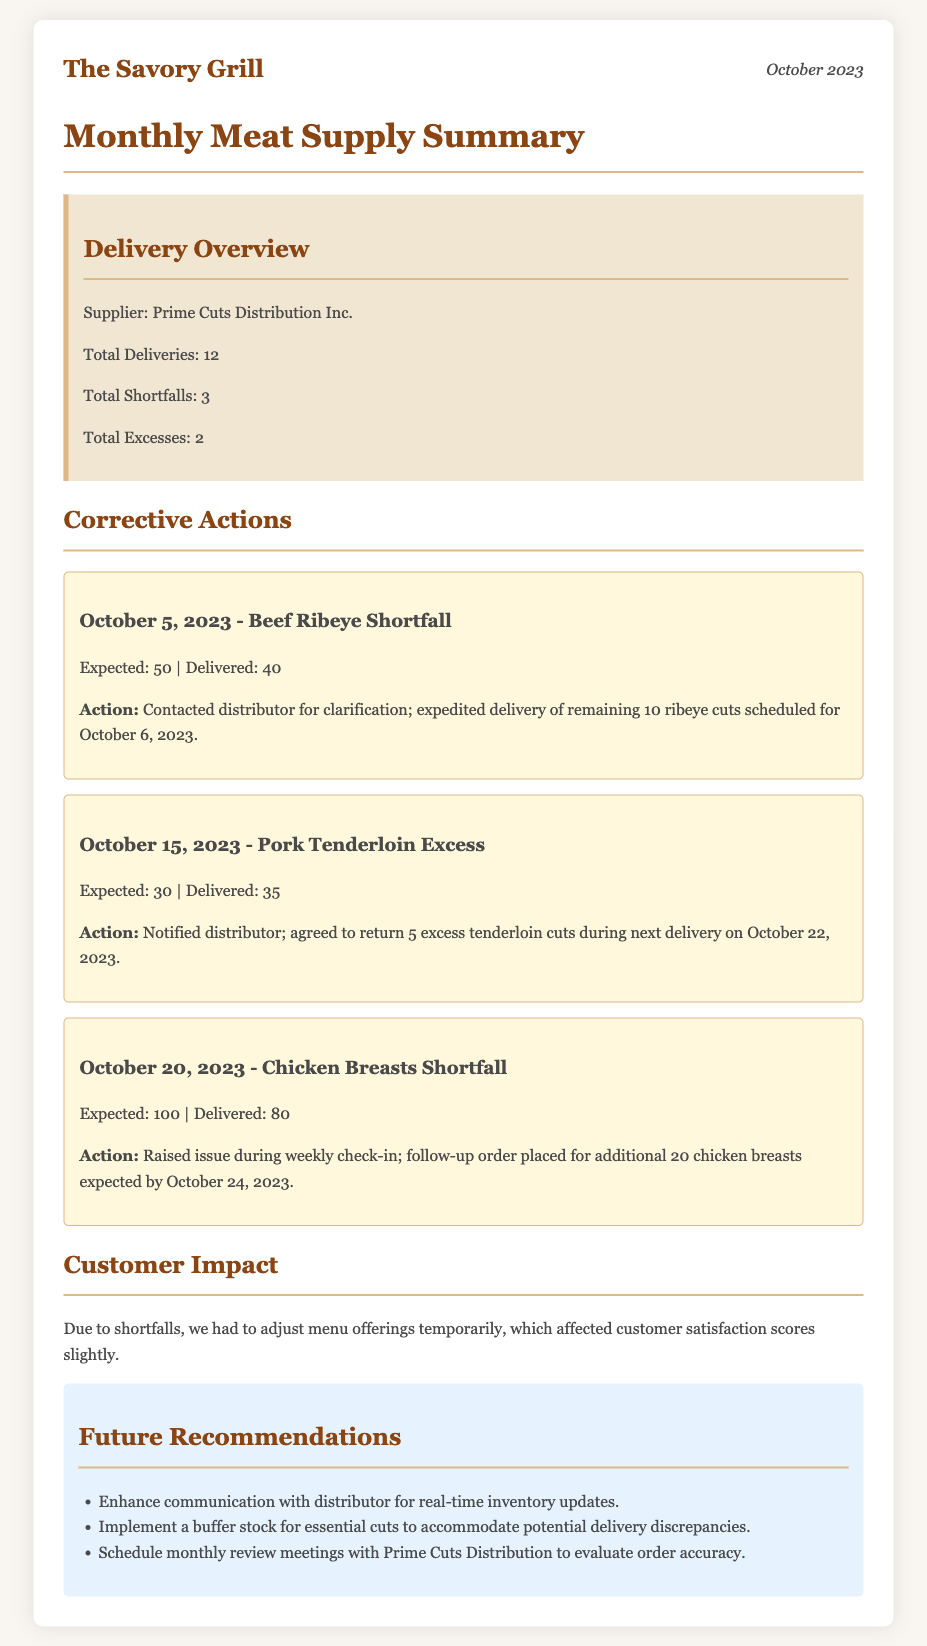what is the name of the supplier? The document states that the supplier is Prime Cuts Distribution Inc.
Answer: Prime Cuts Distribution Inc how many total deliveries were made? The document specifies that there were a total of 12 deliveries made.
Answer: 12 what was the shortfall on October 5, 2023? The document mentions a shortfall where 50 ribeye cuts were expected but only 40 were delivered.
Answer: 10 how many excess pork tenderloins were delivered? According to the document, 5 excess pork tenderloins were delivered.
Answer: 5 what action was taken for the chicken breasts shortfall? The document states that a follow-up order was placed for an additional 20 chicken breasts to be delivered.
Answer: Follow-up order placed what was the customer impact due to shortfalls? The document indicates that the shortfalls led to a temporary adjustment in menu offerings, affecting customer satisfaction scores slightly.
Answer: Affected customer satisfaction how many total shortfalls were there? The document specifies that there were a total of 3 shortfalls recorded.
Answer: 3 what is one recommendation for future orders? The document suggests that one recommendation is to enhance communication with the distributor for real-time inventory updates.
Answer: Enhance communication what is the date for the next delivery of the excess pork tenderloins? According to the document, the agreement was to return the excess during the next delivery scheduled for October 22, 2023.
Answer: October 22, 2023 